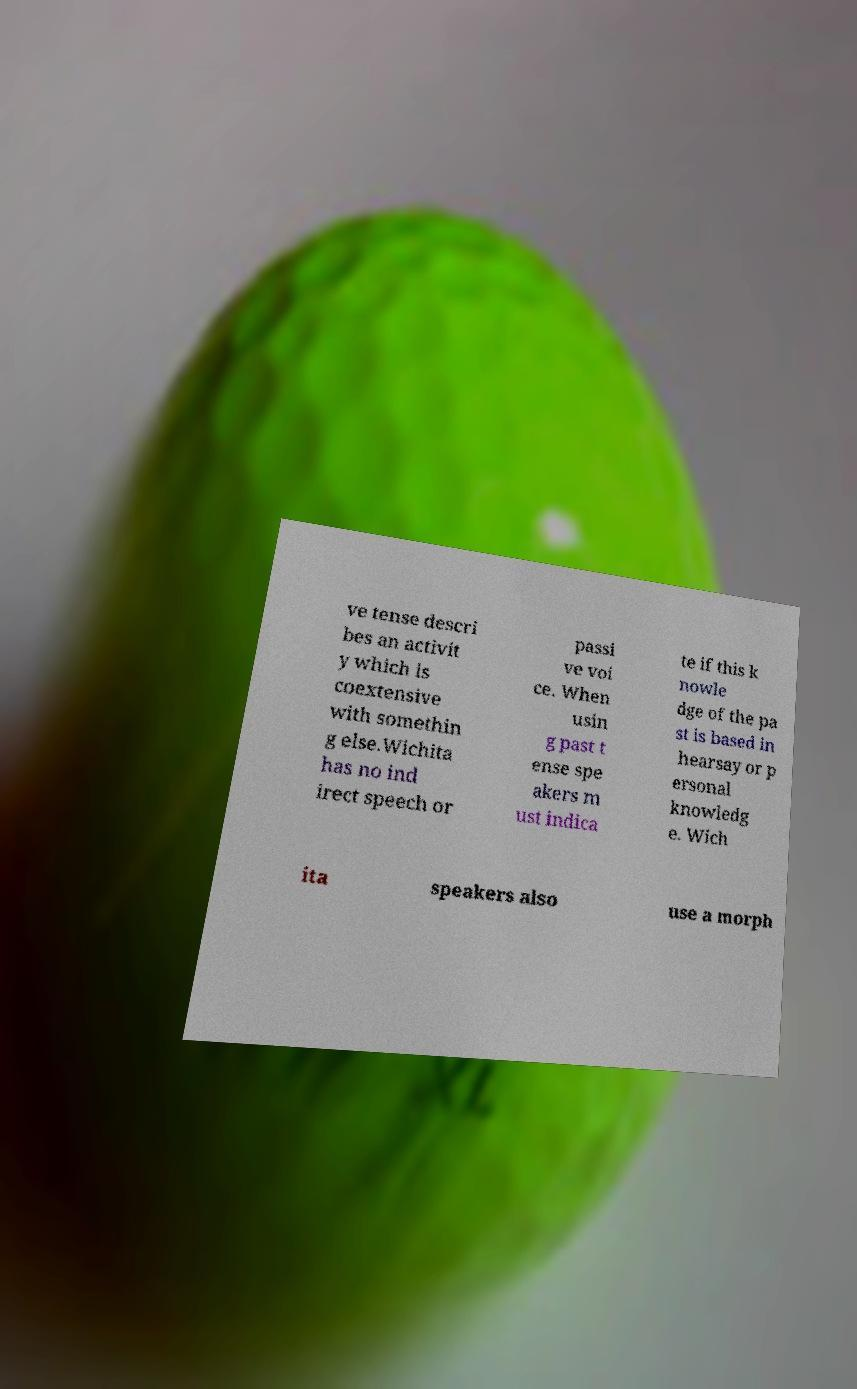There's text embedded in this image that I need extracted. Can you transcribe it verbatim? ve tense descri bes an activit y which is coextensive with somethin g else.Wichita has no ind irect speech or passi ve voi ce. When usin g past t ense spe akers m ust indica te if this k nowle dge of the pa st is based in hearsay or p ersonal knowledg e. Wich ita speakers also use a morph 